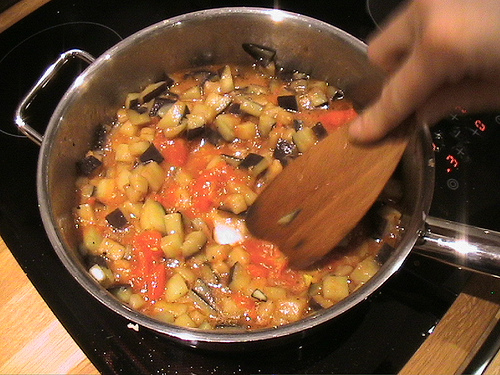<image>
Is there a soup under the spoon? Yes. The soup is positioned underneath the spoon, with the spoon above it in the vertical space. Is there a food behind the vessel? No. The food is not behind the vessel. From this viewpoint, the food appears to be positioned elsewhere in the scene. 